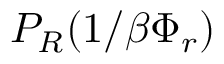<formula> <loc_0><loc_0><loc_500><loc_500>P _ { R } ( 1 / \beta \Phi _ { r } )</formula> 